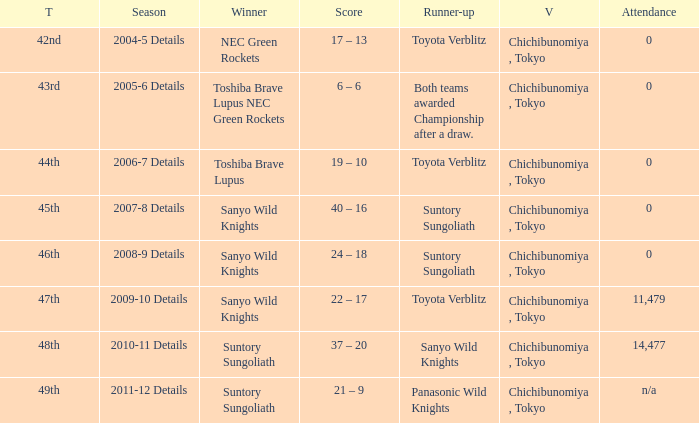What team was the winner when the runner-up shows both teams awarded championship after a draw.? Toshiba Brave Lupus NEC Green Rockets. 